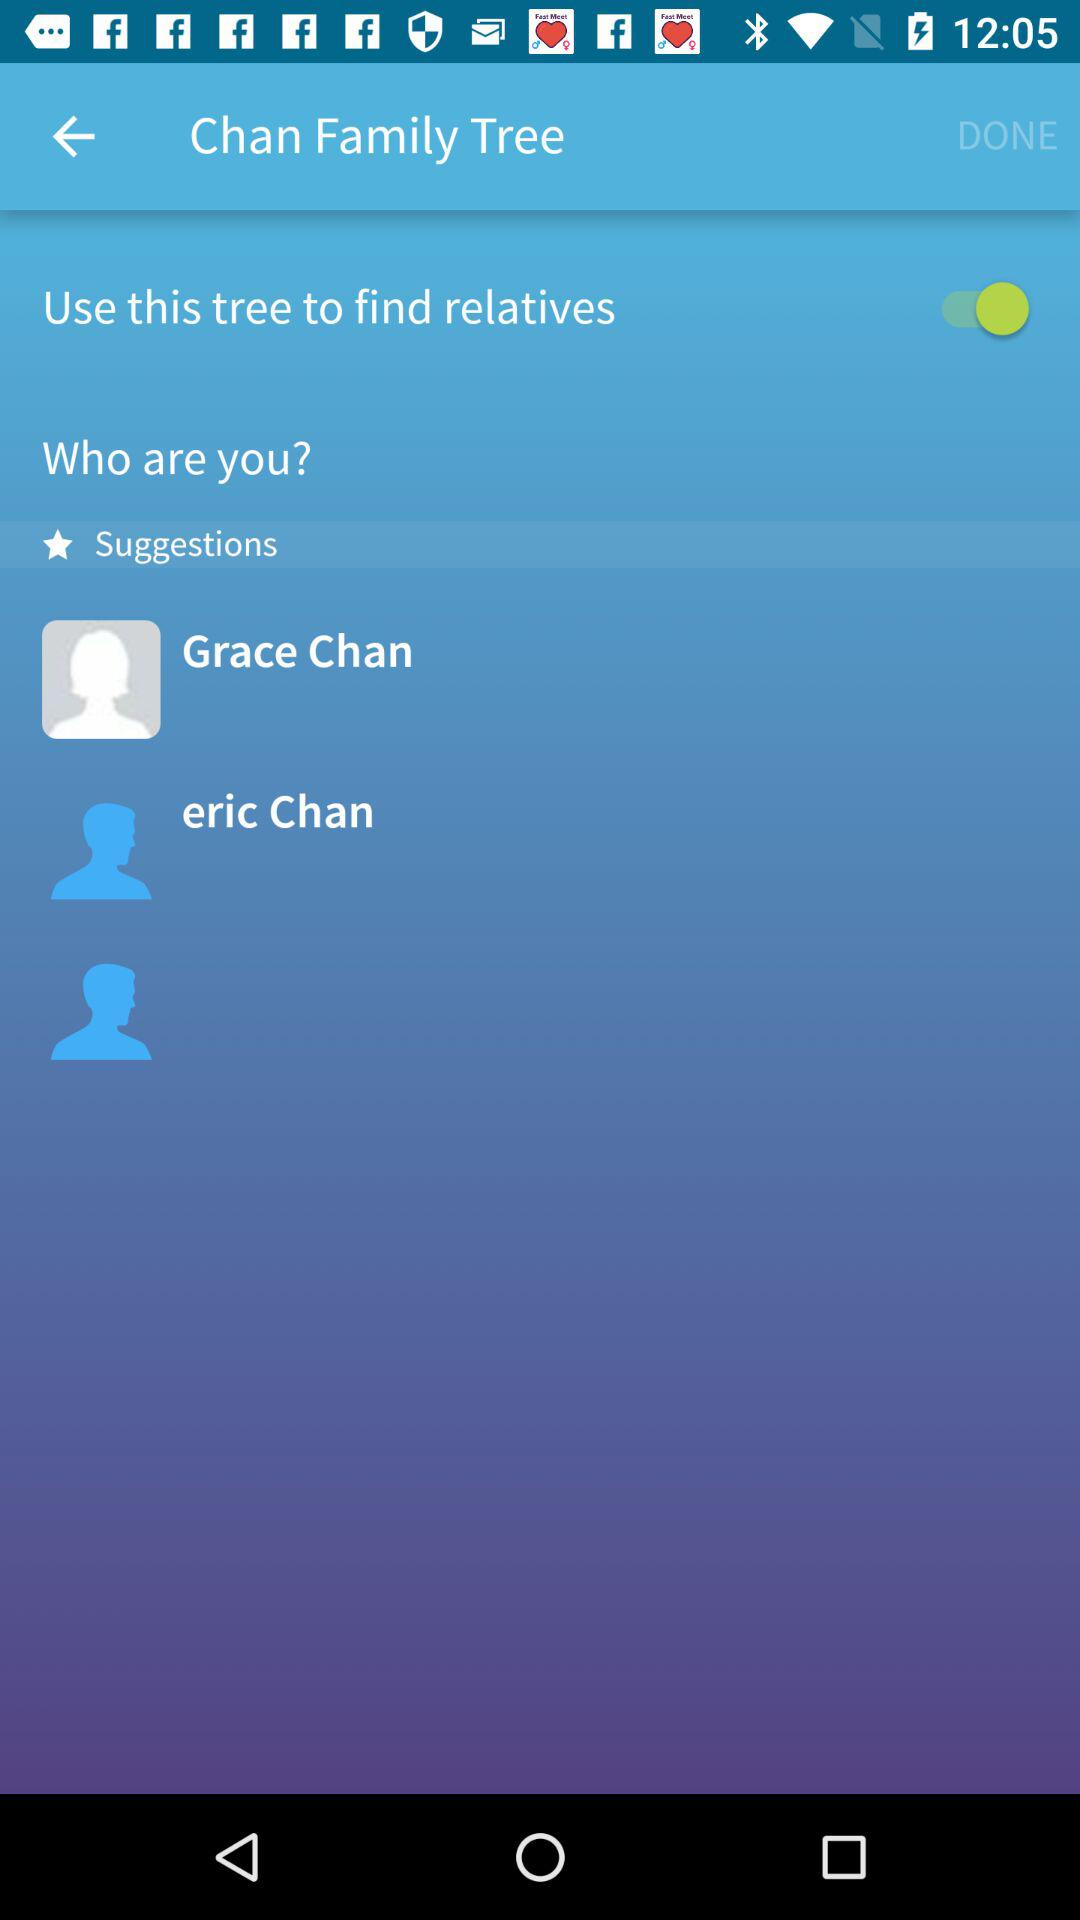Which are the different suggestions? The different suggestions are Grace Chan and Eric Chan. 